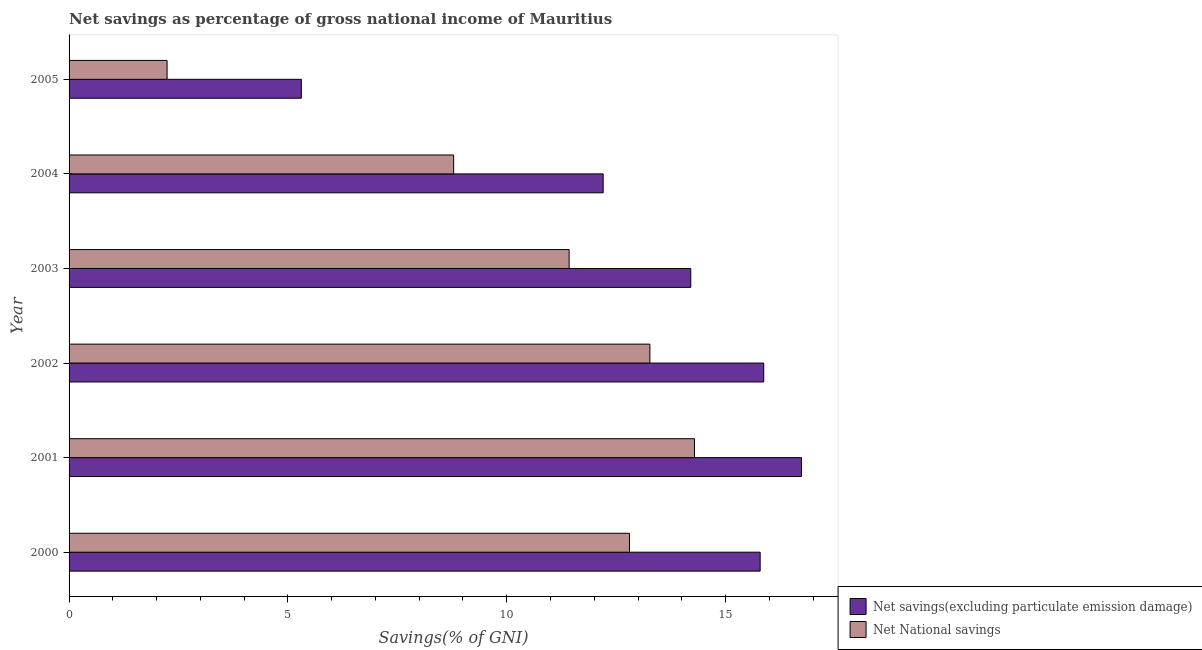How many different coloured bars are there?
Ensure brevity in your answer.  2. Are the number of bars per tick equal to the number of legend labels?
Offer a terse response. Yes. Are the number of bars on each tick of the Y-axis equal?
Provide a succinct answer. Yes. What is the net national savings in 2003?
Your answer should be compact. 11.43. Across all years, what is the maximum net national savings?
Provide a short and direct response. 14.29. Across all years, what is the minimum net savings(excluding particulate emission damage)?
Keep it short and to the point. 5.31. In which year was the net national savings maximum?
Provide a short and direct response. 2001. What is the total net savings(excluding particulate emission damage) in the graph?
Make the answer very short. 80.11. What is the difference between the net national savings in 2000 and that in 2005?
Offer a very short reply. 10.57. What is the difference between the net savings(excluding particulate emission damage) in 2005 and the net national savings in 2004?
Provide a succinct answer. -3.48. What is the average net savings(excluding particulate emission damage) per year?
Provide a succinct answer. 13.35. In the year 2002, what is the difference between the net national savings and net savings(excluding particulate emission damage)?
Ensure brevity in your answer.  -2.6. In how many years, is the net national savings greater than 8 %?
Ensure brevity in your answer.  5. What is the ratio of the net savings(excluding particulate emission damage) in 2001 to that in 2005?
Offer a terse response. 3.15. Is the net savings(excluding particulate emission damage) in 2000 less than that in 2004?
Keep it short and to the point. No. What is the difference between the highest and the second highest net national savings?
Offer a very short reply. 1.02. What is the difference between the highest and the lowest net savings(excluding particulate emission damage)?
Keep it short and to the point. 11.43. In how many years, is the net savings(excluding particulate emission damage) greater than the average net savings(excluding particulate emission damage) taken over all years?
Provide a short and direct response. 4. Is the sum of the net national savings in 2003 and 2005 greater than the maximum net savings(excluding particulate emission damage) across all years?
Your answer should be very brief. No. What does the 2nd bar from the top in 2001 represents?
Provide a succinct answer. Net savings(excluding particulate emission damage). What does the 2nd bar from the bottom in 2000 represents?
Make the answer very short. Net National savings. How many years are there in the graph?
Your response must be concise. 6. What is the difference between two consecutive major ticks on the X-axis?
Offer a very short reply. 5. Does the graph contain grids?
Make the answer very short. No. How are the legend labels stacked?
Offer a terse response. Vertical. What is the title of the graph?
Provide a short and direct response. Net savings as percentage of gross national income of Mauritius. Does "Female labor force" appear as one of the legend labels in the graph?
Offer a very short reply. No. What is the label or title of the X-axis?
Your response must be concise. Savings(% of GNI). What is the Savings(% of GNI) of Net savings(excluding particulate emission damage) in 2000?
Make the answer very short. 15.79. What is the Savings(% of GNI) in Net National savings in 2000?
Make the answer very short. 12.81. What is the Savings(% of GNI) of Net savings(excluding particulate emission damage) in 2001?
Offer a very short reply. 16.73. What is the Savings(% of GNI) of Net National savings in 2001?
Provide a short and direct response. 14.29. What is the Savings(% of GNI) of Net savings(excluding particulate emission damage) in 2002?
Give a very brief answer. 15.87. What is the Savings(% of GNI) in Net National savings in 2002?
Offer a terse response. 13.27. What is the Savings(% of GNI) in Net savings(excluding particulate emission damage) in 2003?
Ensure brevity in your answer.  14.21. What is the Savings(% of GNI) in Net National savings in 2003?
Make the answer very short. 11.43. What is the Savings(% of GNI) of Net savings(excluding particulate emission damage) in 2004?
Offer a very short reply. 12.2. What is the Savings(% of GNI) in Net National savings in 2004?
Offer a terse response. 8.79. What is the Savings(% of GNI) of Net savings(excluding particulate emission damage) in 2005?
Your response must be concise. 5.31. What is the Savings(% of GNI) of Net National savings in 2005?
Ensure brevity in your answer.  2.24. Across all years, what is the maximum Savings(% of GNI) in Net savings(excluding particulate emission damage)?
Your answer should be very brief. 16.73. Across all years, what is the maximum Savings(% of GNI) in Net National savings?
Provide a short and direct response. 14.29. Across all years, what is the minimum Savings(% of GNI) in Net savings(excluding particulate emission damage)?
Keep it short and to the point. 5.31. Across all years, what is the minimum Savings(% of GNI) in Net National savings?
Offer a very short reply. 2.24. What is the total Savings(% of GNI) in Net savings(excluding particulate emission damage) in the graph?
Your response must be concise. 80.11. What is the total Savings(% of GNI) in Net National savings in the graph?
Your answer should be very brief. 62.82. What is the difference between the Savings(% of GNI) of Net savings(excluding particulate emission damage) in 2000 and that in 2001?
Provide a short and direct response. -0.94. What is the difference between the Savings(% of GNI) in Net National savings in 2000 and that in 2001?
Provide a succinct answer. -1.48. What is the difference between the Savings(% of GNI) of Net savings(excluding particulate emission damage) in 2000 and that in 2002?
Ensure brevity in your answer.  -0.08. What is the difference between the Savings(% of GNI) in Net National savings in 2000 and that in 2002?
Keep it short and to the point. -0.47. What is the difference between the Savings(% of GNI) of Net savings(excluding particulate emission damage) in 2000 and that in 2003?
Your answer should be very brief. 1.59. What is the difference between the Savings(% of GNI) in Net National savings in 2000 and that in 2003?
Offer a very short reply. 1.38. What is the difference between the Savings(% of GNI) of Net savings(excluding particulate emission damage) in 2000 and that in 2004?
Your response must be concise. 3.59. What is the difference between the Savings(% of GNI) in Net National savings in 2000 and that in 2004?
Give a very brief answer. 4.02. What is the difference between the Savings(% of GNI) in Net savings(excluding particulate emission damage) in 2000 and that in 2005?
Offer a very short reply. 10.48. What is the difference between the Savings(% of GNI) in Net National savings in 2000 and that in 2005?
Make the answer very short. 10.57. What is the difference between the Savings(% of GNI) of Net savings(excluding particulate emission damage) in 2001 and that in 2002?
Your response must be concise. 0.86. What is the difference between the Savings(% of GNI) of Net National savings in 2001 and that in 2002?
Ensure brevity in your answer.  1.02. What is the difference between the Savings(% of GNI) of Net savings(excluding particulate emission damage) in 2001 and that in 2003?
Your response must be concise. 2.53. What is the difference between the Savings(% of GNI) of Net National savings in 2001 and that in 2003?
Your answer should be compact. 2.86. What is the difference between the Savings(% of GNI) of Net savings(excluding particulate emission damage) in 2001 and that in 2004?
Your response must be concise. 4.53. What is the difference between the Savings(% of GNI) of Net National savings in 2001 and that in 2004?
Give a very brief answer. 5.5. What is the difference between the Savings(% of GNI) in Net savings(excluding particulate emission damage) in 2001 and that in 2005?
Your answer should be compact. 11.43. What is the difference between the Savings(% of GNI) in Net National savings in 2001 and that in 2005?
Your answer should be very brief. 12.05. What is the difference between the Savings(% of GNI) in Net savings(excluding particulate emission damage) in 2002 and that in 2003?
Ensure brevity in your answer.  1.67. What is the difference between the Savings(% of GNI) of Net National savings in 2002 and that in 2003?
Your answer should be compact. 1.84. What is the difference between the Savings(% of GNI) in Net savings(excluding particulate emission damage) in 2002 and that in 2004?
Make the answer very short. 3.67. What is the difference between the Savings(% of GNI) in Net National savings in 2002 and that in 2004?
Give a very brief answer. 4.48. What is the difference between the Savings(% of GNI) in Net savings(excluding particulate emission damage) in 2002 and that in 2005?
Your response must be concise. 10.57. What is the difference between the Savings(% of GNI) in Net National savings in 2002 and that in 2005?
Keep it short and to the point. 11.03. What is the difference between the Savings(% of GNI) of Net savings(excluding particulate emission damage) in 2003 and that in 2004?
Keep it short and to the point. 2. What is the difference between the Savings(% of GNI) of Net National savings in 2003 and that in 2004?
Make the answer very short. 2.64. What is the difference between the Savings(% of GNI) in Net savings(excluding particulate emission damage) in 2003 and that in 2005?
Keep it short and to the point. 8.9. What is the difference between the Savings(% of GNI) of Net National savings in 2003 and that in 2005?
Provide a short and direct response. 9.19. What is the difference between the Savings(% of GNI) in Net savings(excluding particulate emission damage) in 2004 and that in 2005?
Give a very brief answer. 6.9. What is the difference between the Savings(% of GNI) in Net National savings in 2004 and that in 2005?
Make the answer very short. 6.55. What is the difference between the Savings(% of GNI) of Net savings(excluding particulate emission damage) in 2000 and the Savings(% of GNI) of Net National savings in 2001?
Provide a succinct answer. 1.5. What is the difference between the Savings(% of GNI) in Net savings(excluding particulate emission damage) in 2000 and the Savings(% of GNI) in Net National savings in 2002?
Make the answer very short. 2.52. What is the difference between the Savings(% of GNI) of Net savings(excluding particulate emission damage) in 2000 and the Savings(% of GNI) of Net National savings in 2003?
Make the answer very short. 4.36. What is the difference between the Savings(% of GNI) in Net savings(excluding particulate emission damage) in 2000 and the Savings(% of GNI) in Net National savings in 2004?
Provide a short and direct response. 7. What is the difference between the Savings(% of GNI) in Net savings(excluding particulate emission damage) in 2000 and the Savings(% of GNI) in Net National savings in 2005?
Provide a succinct answer. 13.55. What is the difference between the Savings(% of GNI) in Net savings(excluding particulate emission damage) in 2001 and the Savings(% of GNI) in Net National savings in 2002?
Keep it short and to the point. 3.46. What is the difference between the Savings(% of GNI) in Net savings(excluding particulate emission damage) in 2001 and the Savings(% of GNI) in Net National savings in 2003?
Your answer should be very brief. 5.31. What is the difference between the Savings(% of GNI) of Net savings(excluding particulate emission damage) in 2001 and the Savings(% of GNI) of Net National savings in 2004?
Make the answer very short. 7.95. What is the difference between the Savings(% of GNI) of Net savings(excluding particulate emission damage) in 2001 and the Savings(% of GNI) of Net National savings in 2005?
Make the answer very short. 14.49. What is the difference between the Savings(% of GNI) of Net savings(excluding particulate emission damage) in 2002 and the Savings(% of GNI) of Net National savings in 2003?
Provide a short and direct response. 4.45. What is the difference between the Savings(% of GNI) of Net savings(excluding particulate emission damage) in 2002 and the Savings(% of GNI) of Net National savings in 2004?
Provide a succinct answer. 7.09. What is the difference between the Savings(% of GNI) in Net savings(excluding particulate emission damage) in 2002 and the Savings(% of GNI) in Net National savings in 2005?
Your answer should be very brief. 13.63. What is the difference between the Savings(% of GNI) in Net savings(excluding particulate emission damage) in 2003 and the Savings(% of GNI) in Net National savings in 2004?
Provide a succinct answer. 5.42. What is the difference between the Savings(% of GNI) in Net savings(excluding particulate emission damage) in 2003 and the Savings(% of GNI) in Net National savings in 2005?
Offer a terse response. 11.97. What is the difference between the Savings(% of GNI) in Net savings(excluding particulate emission damage) in 2004 and the Savings(% of GNI) in Net National savings in 2005?
Give a very brief answer. 9.96. What is the average Savings(% of GNI) in Net savings(excluding particulate emission damage) per year?
Give a very brief answer. 13.35. What is the average Savings(% of GNI) of Net National savings per year?
Your answer should be very brief. 10.47. In the year 2000, what is the difference between the Savings(% of GNI) in Net savings(excluding particulate emission damage) and Savings(% of GNI) in Net National savings?
Offer a terse response. 2.99. In the year 2001, what is the difference between the Savings(% of GNI) of Net savings(excluding particulate emission damage) and Savings(% of GNI) of Net National savings?
Your response must be concise. 2.44. In the year 2002, what is the difference between the Savings(% of GNI) in Net savings(excluding particulate emission damage) and Savings(% of GNI) in Net National savings?
Your response must be concise. 2.6. In the year 2003, what is the difference between the Savings(% of GNI) in Net savings(excluding particulate emission damage) and Savings(% of GNI) in Net National savings?
Make the answer very short. 2.78. In the year 2004, what is the difference between the Savings(% of GNI) in Net savings(excluding particulate emission damage) and Savings(% of GNI) in Net National savings?
Offer a very short reply. 3.42. In the year 2005, what is the difference between the Savings(% of GNI) in Net savings(excluding particulate emission damage) and Savings(% of GNI) in Net National savings?
Offer a very short reply. 3.07. What is the ratio of the Savings(% of GNI) of Net savings(excluding particulate emission damage) in 2000 to that in 2001?
Make the answer very short. 0.94. What is the ratio of the Savings(% of GNI) in Net National savings in 2000 to that in 2001?
Make the answer very short. 0.9. What is the ratio of the Savings(% of GNI) in Net savings(excluding particulate emission damage) in 2000 to that in 2002?
Your answer should be very brief. 0.99. What is the ratio of the Savings(% of GNI) in Net National savings in 2000 to that in 2002?
Offer a very short reply. 0.96. What is the ratio of the Savings(% of GNI) in Net savings(excluding particulate emission damage) in 2000 to that in 2003?
Give a very brief answer. 1.11. What is the ratio of the Savings(% of GNI) of Net National savings in 2000 to that in 2003?
Your response must be concise. 1.12. What is the ratio of the Savings(% of GNI) of Net savings(excluding particulate emission damage) in 2000 to that in 2004?
Your answer should be compact. 1.29. What is the ratio of the Savings(% of GNI) in Net National savings in 2000 to that in 2004?
Your answer should be very brief. 1.46. What is the ratio of the Savings(% of GNI) in Net savings(excluding particulate emission damage) in 2000 to that in 2005?
Keep it short and to the point. 2.98. What is the ratio of the Savings(% of GNI) in Net National savings in 2000 to that in 2005?
Offer a very short reply. 5.72. What is the ratio of the Savings(% of GNI) of Net savings(excluding particulate emission damage) in 2001 to that in 2002?
Offer a very short reply. 1.05. What is the ratio of the Savings(% of GNI) in Net National savings in 2001 to that in 2002?
Keep it short and to the point. 1.08. What is the ratio of the Savings(% of GNI) of Net savings(excluding particulate emission damage) in 2001 to that in 2003?
Give a very brief answer. 1.18. What is the ratio of the Savings(% of GNI) in Net National savings in 2001 to that in 2003?
Give a very brief answer. 1.25. What is the ratio of the Savings(% of GNI) in Net savings(excluding particulate emission damage) in 2001 to that in 2004?
Give a very brief answer. 1.37. What is the ratio of the Savings(% of GNI) in Net National savings in 2001 to that in 2004?
Ensure brevity in your answer.  1.63. What is the ratio of the Savings(% of GNI) in Net savings(excluding particulate emission damage) in 2001 to that in 2005?
Make the answer very short. 3.15. What is the ratio of the Savings(% of GNI) of Net National savings in 2001 to that in 2005?
Ensure brevity in your answer.  6.38. What is the ratio of the Savings(% of GNI) in Net savings(excluding particulate emission damage) in 2002 to that in 2003?
Make the answer very short. 1.12. What is the ratio of the Savings(% of GNI) in Net National savings in 2002 to that in 2003?
Make the answer very short. 1.16. What is the ratio of the Savings(% of GNI) of Net savings(excluding particulate emission damage) in 2002 to that in 2004?
Make the answer very short. 1.3. What is the ratio of the Savings(% of GNI) of Net National savings in 2002 to that in 2004?
Your answer should be compact. 1.51. What is the ratio of the Savings(% of GNI) in Net savings(excluding particulate emission damage) in 2002 to that in 2005?
Offer a very short reply. 2.99. What is the ratio of the Savings(% of GNI) in Net National savings in 2002 to that in 2005?
Offer a terse response. 5.92. What is the ratio of the Savings(% of GNI) of Net savings(excluding particulate emission damage) in 2003 to that in 2004?
Your answer should be very brief. 1.16. What is the ratio of the Savings(% of GNI) of Net National savings in 2003 to that in 2004?
Make the answer very short. 1.3. What is the ratio of the Savings(% of GNI) of Net savings(excluding particulate emission damage) in 2003 to that in 2005?
Your answer should be very brief. 2.68. What is the ratio of the Savings(% of GNI) in Net National savings in 2003 to that in 2005?
Offer a very short reply. 5.1. What is the ratio of the Savings(% of GNI) of Net savings(excluding particulate emission damage) in 2004 to that in 2005?
Offer a terse response. 2.3. What is the ratio of the Savings(% of GNI) of Net National savings in 2004 to that in 2005?
Keep it short and to the point. 3.92. What is the difference between the highest and the second highest Savings(% of GNI) in Net savings(excluding particulate emission damage)?
Make the answer very short. 0.86. What is the difference between the highest and the second highest Savings(% of GNI) in Net National savings?
Your answer should be very brief. 1.02. What is the difference between the highest and the lowest Savings(% of GNI) in Net savings(excluding particulate emission damage)?
Offer a very short reply. 11.43. What is the difference between the highest and the lowest Savings(% of GNI) of Net National savings?
Provide a succinct answer. 12.05. 